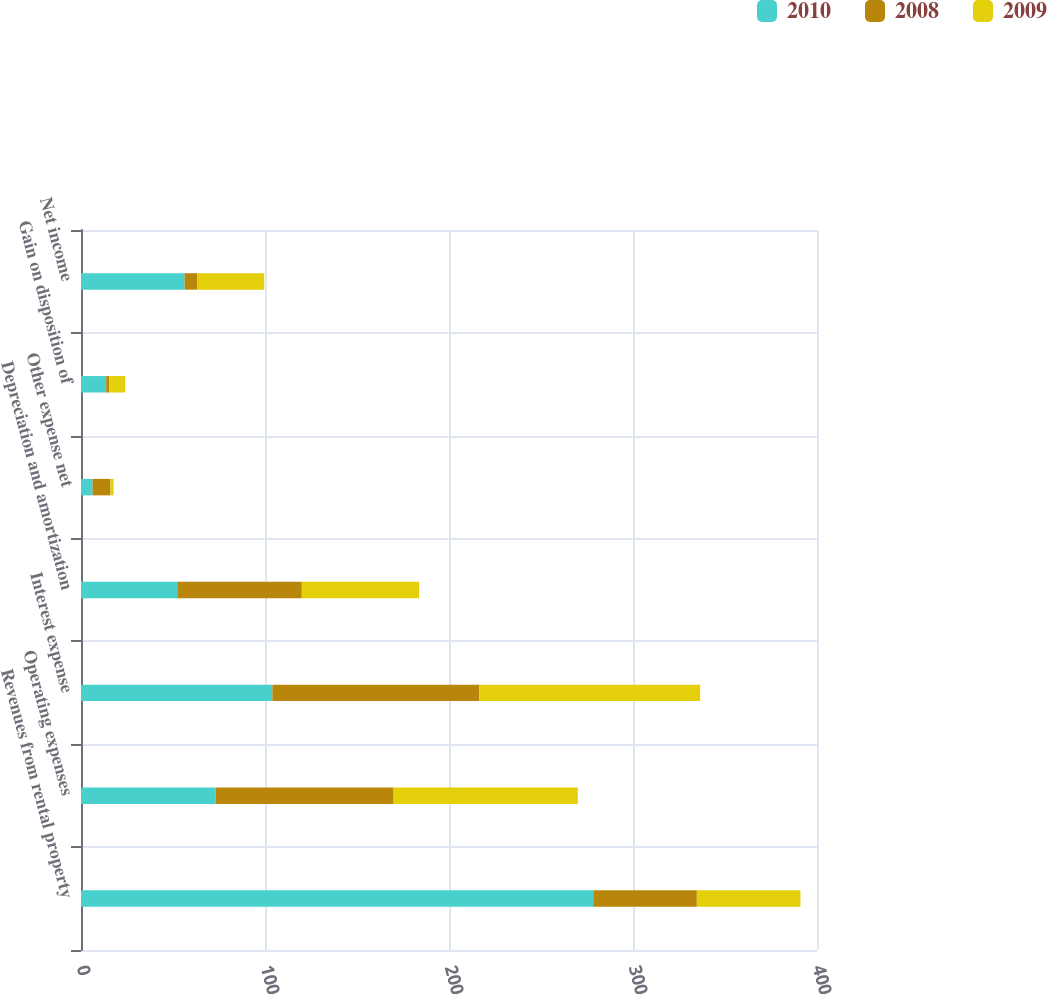Convert chart. <chart><loc_0><loc_0><loc_500><loc_500><stacked_bar_chart><ecel><fcel>Revenues from rental property<fcel>Operating expenses<fcel>Interest expense<fcel>Depreciation and amortization<fcel>Other expense net<fcel>Gain on disposition of<fcel>Net income<nl><fcel>2010<fcel>278.4<fcel>73.2<fcel>104<fcel>52.3<fcel>6.3<fcel>13.7<fcel>56.3<nl><fcel>2008<fcel>56.3<fcel>96.7<fcel>112.5<fcel>67.7<fcel>9.7<fcel>1.7<fcel>7<nl><fcel>2009<fcel>56.3<fcel>100.1<fcel>120<fcel>63.7<fcel>1.7<fcel>8.5<fcel>36.3<nl></chart> 